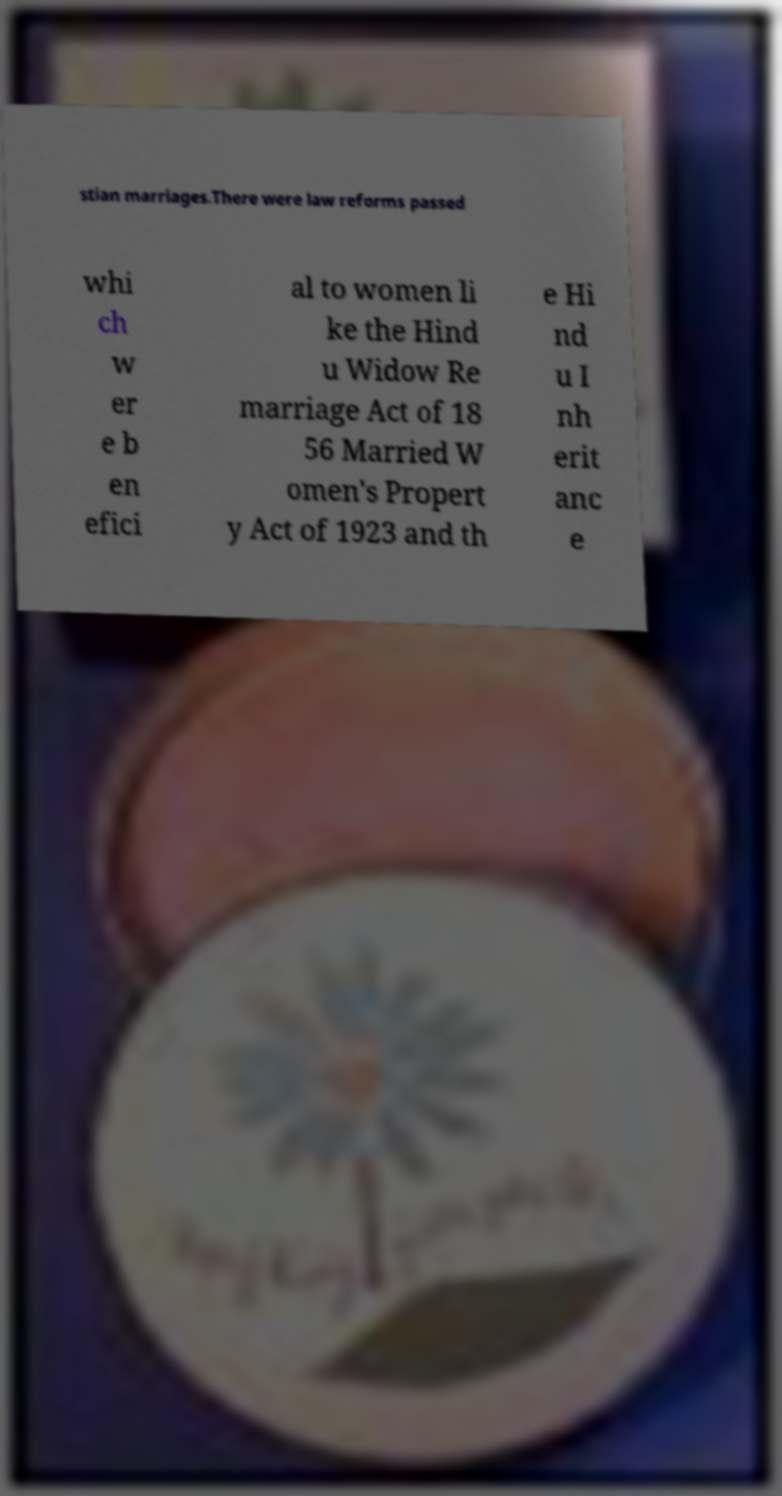Can you accurately transcribe the text from the provided image for me? stian marriages.There were law reforms passed whi ch w er e b en efici al to women li ke the Hind u Widow Re marriage Act of 18 56 Married W omen's Propert y Act of 1923 and th e Hi nd u I nh erit anc e 